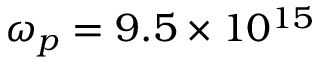Convert formula to latex. <formula><loc_0><loc_0><loc_500><loc_500>\omega _ { p } = 9 . 5 \times 1 0 ^ { 1 5 }</formula> 